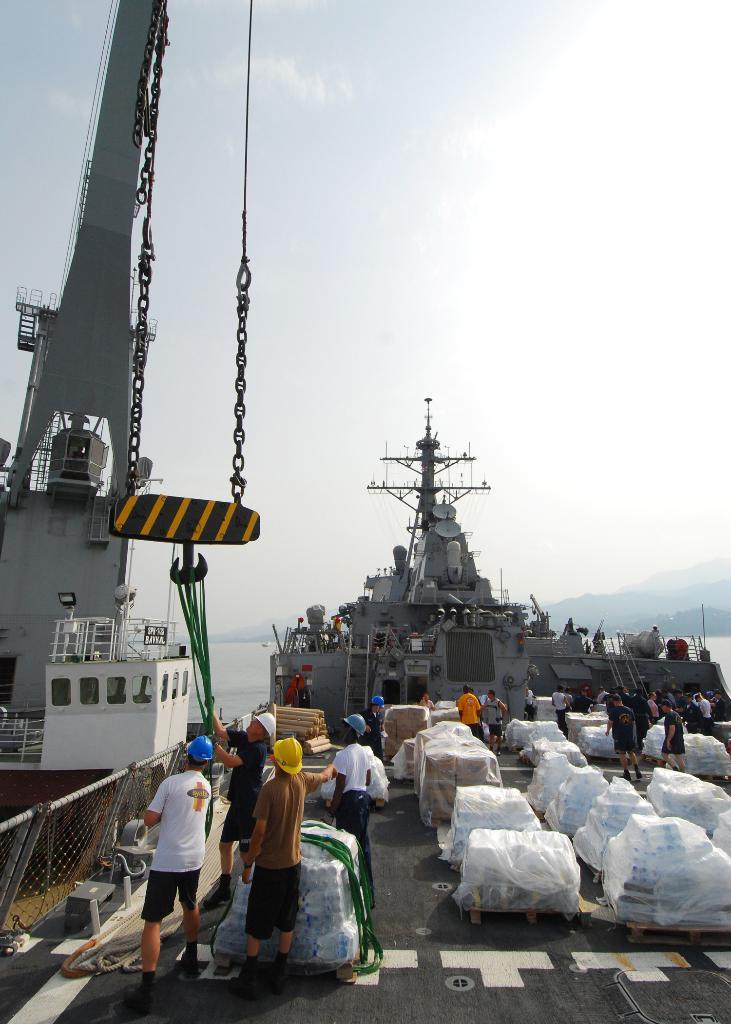In one or two sentences, can you explain what this image depicts? In the center of the image there are persons standing on the road. Beside them there are water bottles. Behind them there are two ships. In the background there is water, trees, mountains and sky. 